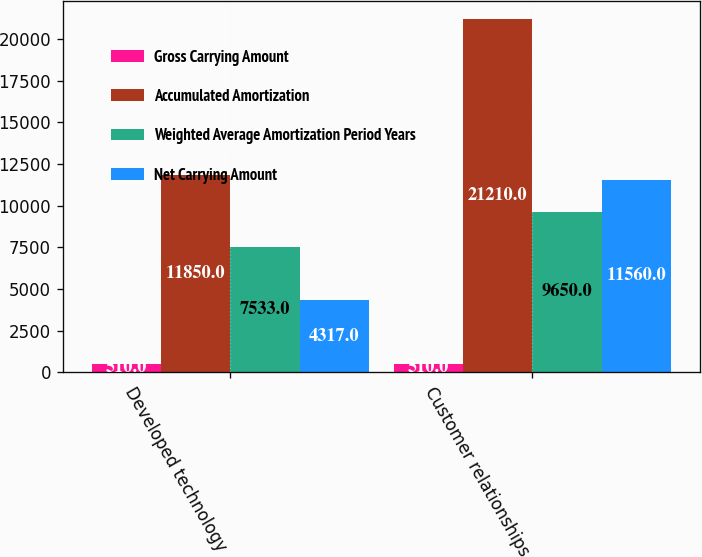Convert chart. <chart><loc_0><loc_0><loc_500><loc_500><stacked_bar_chart><ecel><fcel>Developed technology<fcel>Customer relationships<nl><fcel>Gross Carrying Amount<fcel>510<fcel>510<nl><fcel>Accumulated Amortization<fcel>11850<fcel>21210<nl><fcel>Weighted Average Amortization Period Years<fcel>7533<fcel>9650<nl><fcel>Net Carrying Amount<fcel>4317<fcel>11560<nl></chart> 